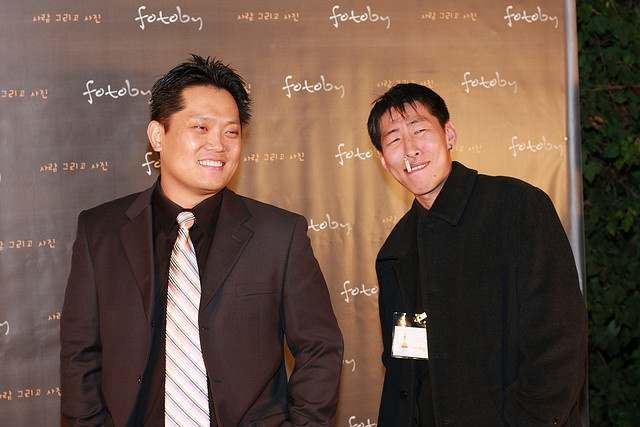Describe the objects in this image and their specific colors. I can see people in gray, black, white, and tan tones, people in gray, black, salmon, and white tones, and tie in gray, white, darkgray, and lightpink tones in this image. 